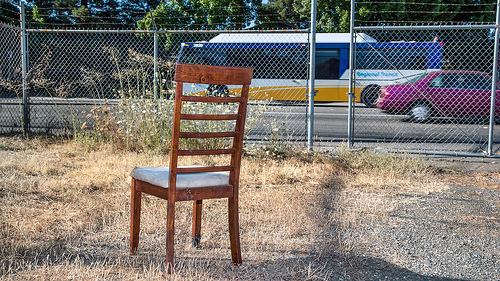<image>
Is the bus next to the car? Yes. The bus is positioned adjacent to the car, located nearby in the same general area. Is there a fence behind the car? No. The fence is not behind the car. From this viewpoint, the fence appears to be positioned elsewhere in the scene. 